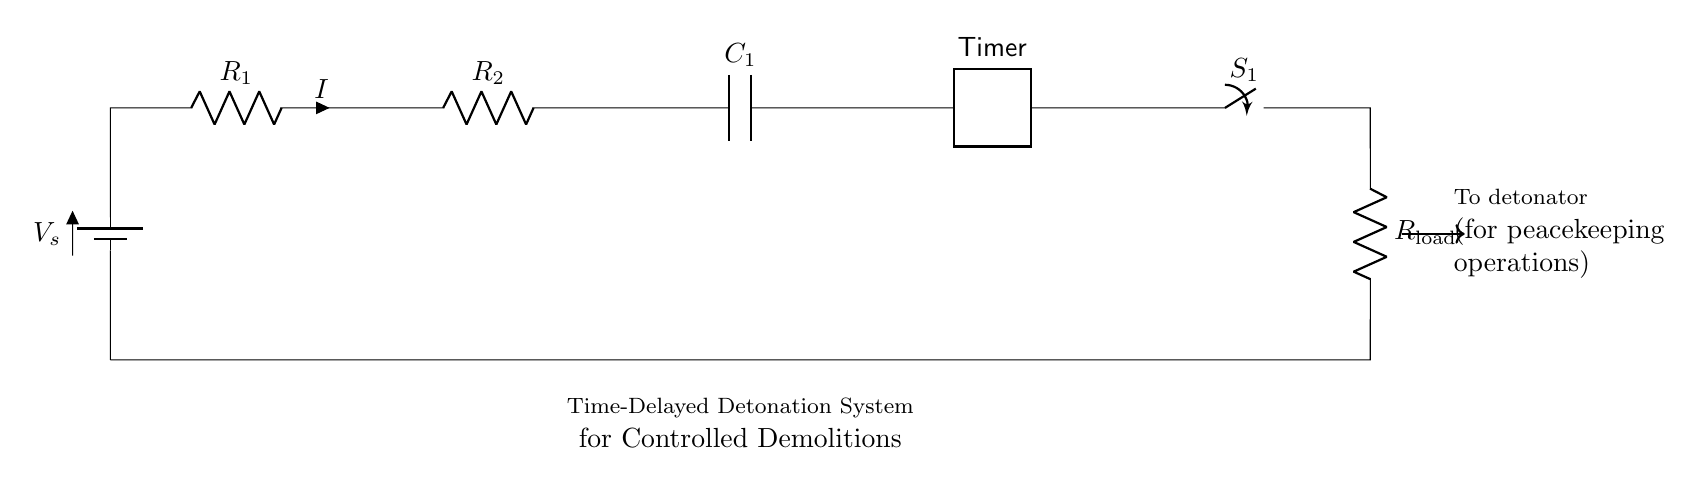What is the main function of this circuit? The main function of this circuit is to provide a time-delayed detonation system for controlled demolitions, allowing for safety and coordination during operations.
Answer: time-delayed detonation system What components make up this series circuit? The components in this circuit include a battery, two resistors, a capacitor, a timer, a switch, and a load resistor. Each part serves a specific role in the functionality of the circuit.
Answer: battery, resistors, capacitor, timer, switch, load resistor What is the role of the capacitor in this circuit? The capacitor in this circuit stores electrical energy and releases it at a controlled time, contributing to the timing mechanism for the detonation sequence.
Answer: timing mechanism What type of switch is used here? The diagram indicates a switch labeled S1. It can be assumed to be a manual or electronic switch that controls the connection in the circuit, in line with typical detonation systems.
Answer: S1 (switch) How does the timer interact with the rest of the circuit? The timer controls the delay before the switch allows current to flow to the detonator. It is crucial in ensuring that the detonation occurs at the intended time, following the circuit's activation.
Answer: controls detonation timing Which component determines the current flow in the circuit? The resistors R1 and R2 determine the current flow by introducing resistance that affects the overall impedance in the circuit; the current is influenced by the values of these resistors and the applied voltage.
Answer: R1 and R2 (resistors) What will happen if the switch S1 is closed? Closing the switch S1 will complete the circuit, allowing current to flow through the load resistor and triggering the detonator once the timer reaches its pre-set duration.
Answer: current flows, triggering detonation 